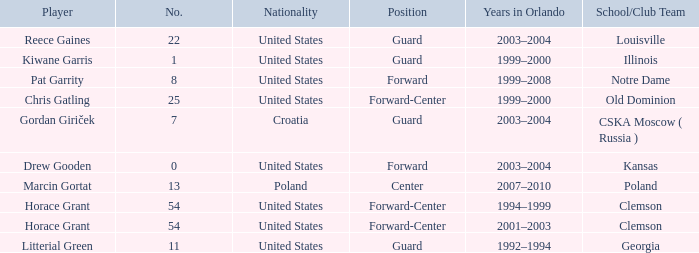How many players belong to Notre Dame? 1.0. 